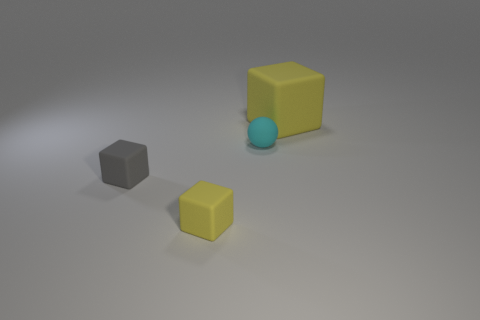Subtract all big rubber cubes. How many cubes are left? 2 Add 1 small yellow rubber blocks. How many objects exist? 5 Subtract all gray cubes. How many cubes are left? 2 Subtract all cubes. How many objects are left? 1 Subtract 2 blocks. How many blocks are left? 1 Subtract all gray blocks. Subtract all yellow balls. How many blocks are left? 2 Subtract all red cylinders. How many gray balls are left? 0 Subtract all small gray cubes. Subtract all tiny gray objects. How many objects are left? 2 Add 3 tiny matte blocks. How many tiny matte blocks are left? 5 Add 4 big rubber cubes. How many big rubber cubes exist? 5 